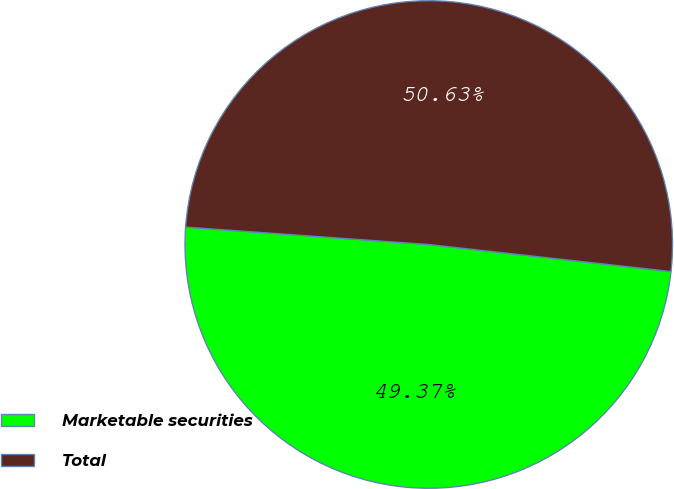Convert chart to OTSL. <chart><loc_0><loc_0><loc_500><loc_500><pie_chart><fcel>Marketable securities<fcel>Total<nl><fcel>49.37%<fcel>50.63%<nl></chart> 